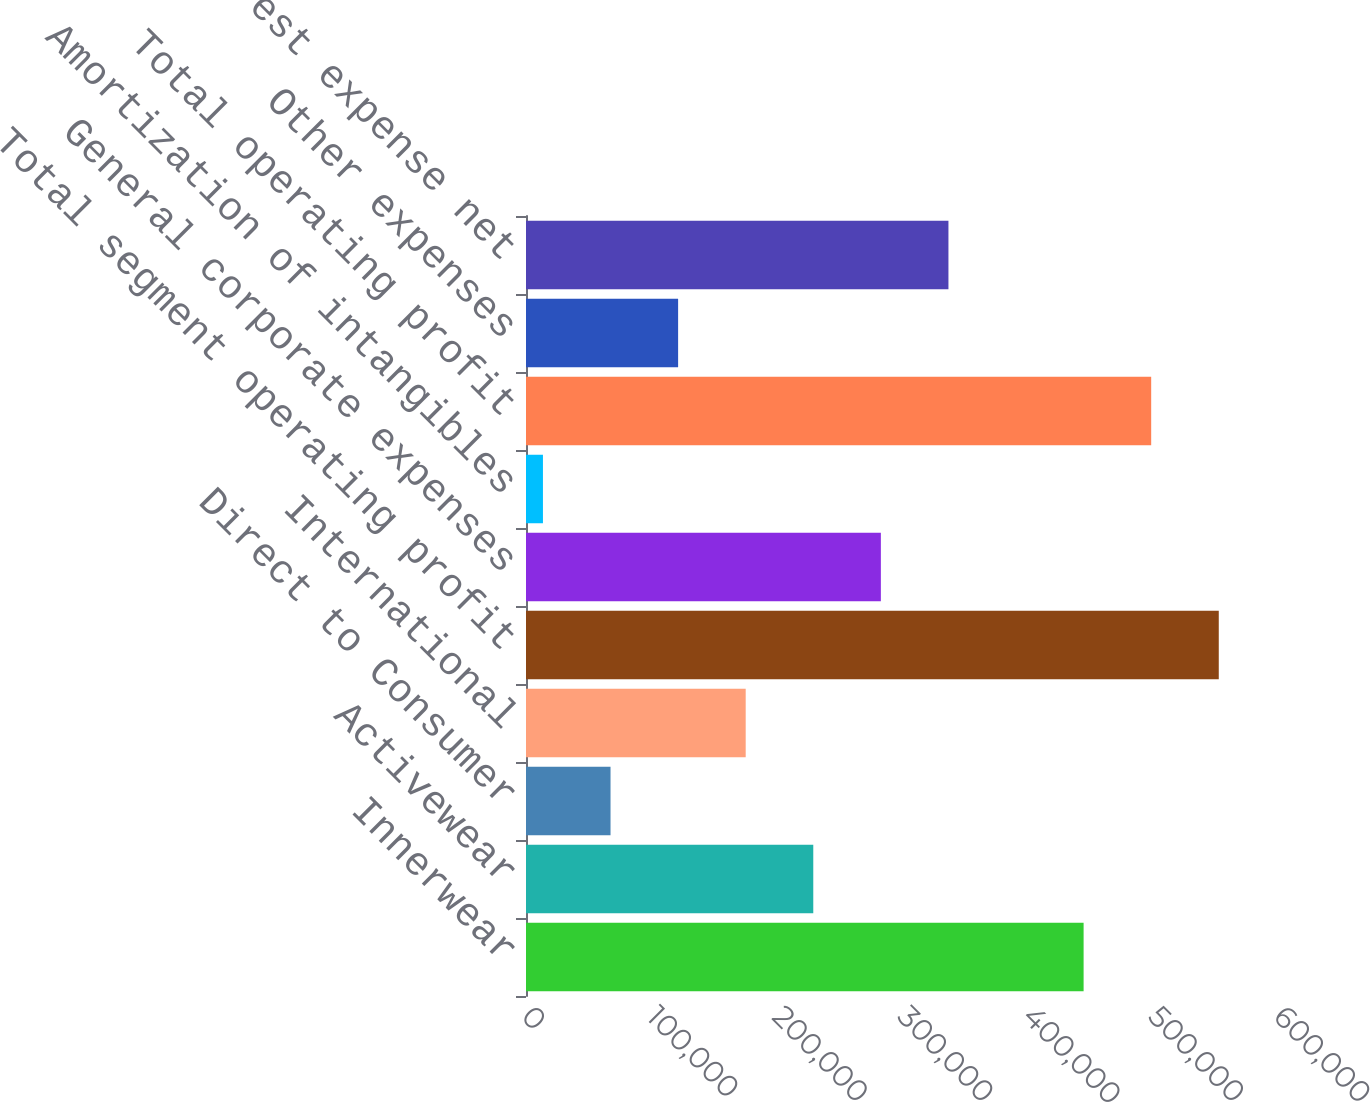Convert chart to OTSL. <chart><loc_0><loc_0><loc_500><loc_500><bar_chart><fcel>Innerwear<fcel>Activewear<fcel>Direct to Consumer<fcel>International<fcel>Total segment operating profit<fcel>General corporate expenses<fcel>Amortization of intangibles<fcel>Total operating profit<fcel>Other expenses<fcel>Interest expense net<nl><fcel>444898<fcel>229212<fcel>67447.5<fcel>175290<fcel>552741<fcel>283134<fcel>13526<fcel>498820<fcel>121369<fcel>337055<nl></chart> 